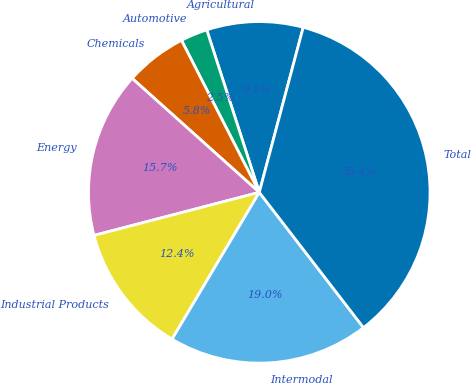Convert chart. <chart><loc_0><loc_0><loc_500><loc_500><pie_chart><fcel>Agricultural<fcel>Automotive<fcel>Chemicals<fcel>Energy<fcel>Industrial Products<fcel>Intermodal<fcel>Total<nl><fcel>9.12%<fcel>2.55%<fcel>5.84%<fcel>15.69%<fcel>12.41%<fcel>18.98%<fcel>35.41%<nl></chart> 